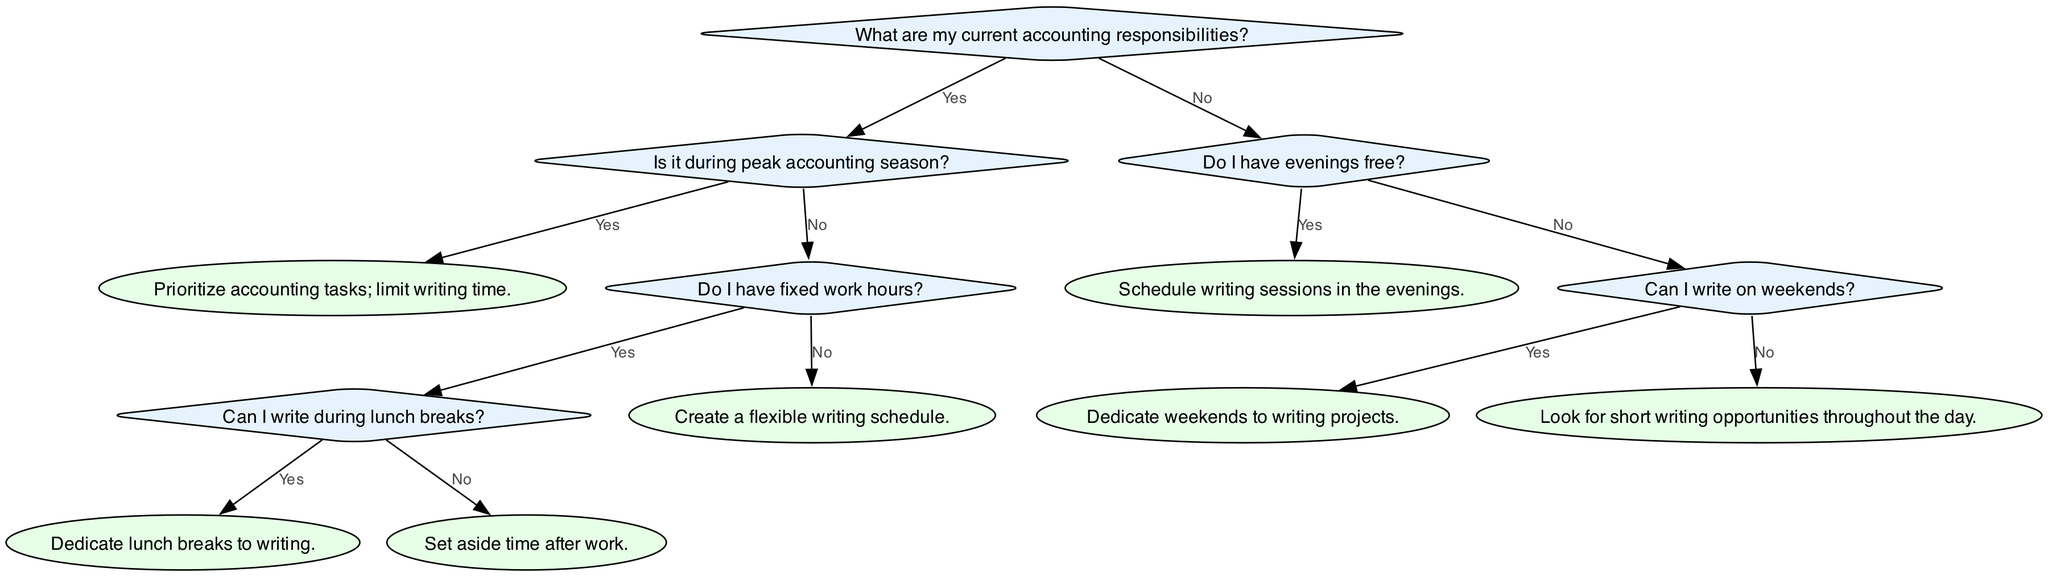What are my current accounting responsibilities? This is the root question of the decision tree. It determines the flow of the decision-making process based on whether the person has current accounting responsibilities or not.
Answer: What are my current accounting responsibilities? Is it during peak accounting season? This question follows the first decision point if the person does have accounting responsibilities. It helps identify if the current workload is high enough to require prioritizing accounting tasks over writing.
Answer: Is it during peak accounting season? What should I do if I have fixed work hours? This question branches out from the "No" answer of whether it's peak accounting season. It assesses whether the individual can allocate writing time during structured hours.
Answer: Do I have fixed work hours? Can I write during lunch breaks? This question comes from the "Yes" branch under having fixed work hours. It further narrows down the options for writing based on whether lunch breaks can be utilized for writing.
Answer: Can I write during lunch breaks? How do I prioritize writing if I don't have fixed work hours? If the answer is "No" to having fixed work hours, this question leads to a suggestion for creating a flexible writing schedule, which is a more general approach adaptable to varied circumstances.
Answer: Create a flexible writing schedule What action should I take if it's not peak season and I don't have evenings free? This question arises from navigating through the tree and leads to alternatives if evenings and peak times are ruled out. The diagram suggests looking for short writing opportunities throughout the day.
Answer: Look for short writing opportunities throughout the day How many main branches are there after the first decision point? This question requires counting the major outcomes after initially assessing whether the person has accounting responsibilities. There are two main branches based on the Yes/No answers to the first question.
Answer: Two main branches What is the action recommended if I can write on weekends? This question focuses on a specific scenario under the decision-making tree. It leads to the advice of dedicating weekends to writing projects if that option exists.
Answer: Dedicate weekends to writing projects What does the diagram suggest if I write during lunch breaks? This inquiry targets a specific node representing an action in the decision tree, confirming that writing sessions can be accommodated during lunchtime.
Answer: Dedicate lunch breaks to writing 